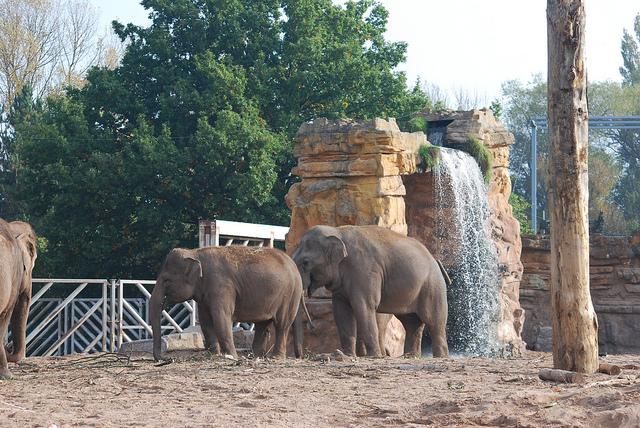What is near the elephants?

Choices:
A) drones
B) toddlers
C) eggs
D) trees trees 